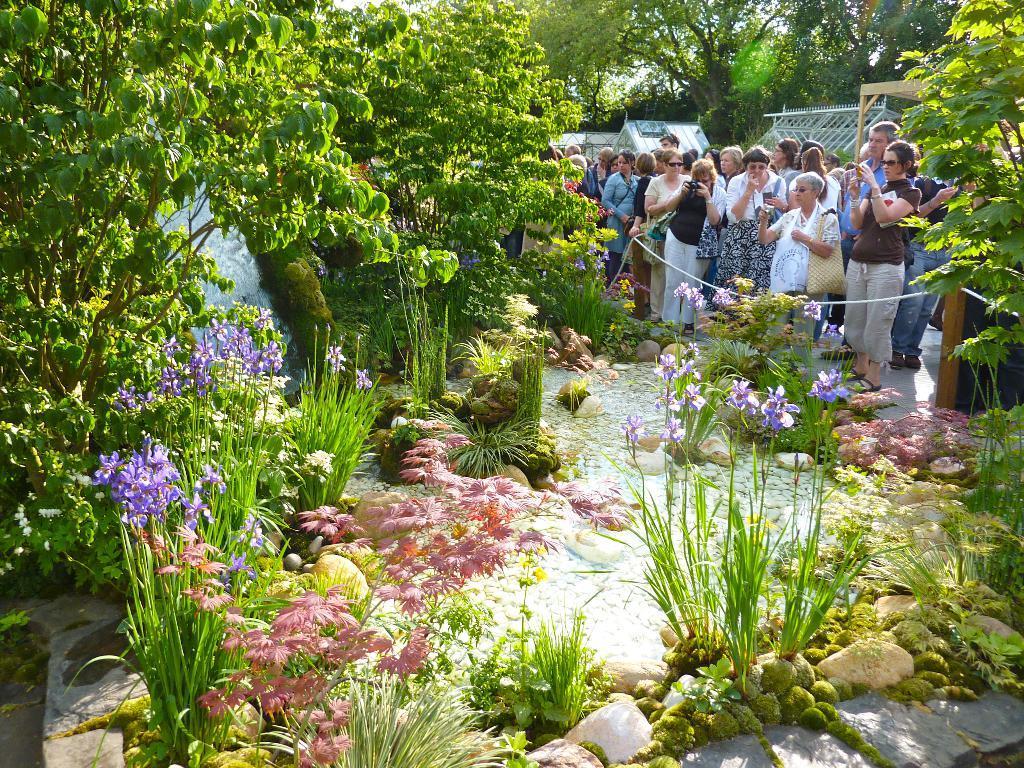Can you describe this image briefly? In this image we can see a group of people standing on the floor. In that some people are holding the cameras and mobile phones. We can also see the water, trees, plants with flowers and some stones. On the backside we can see some tents. 